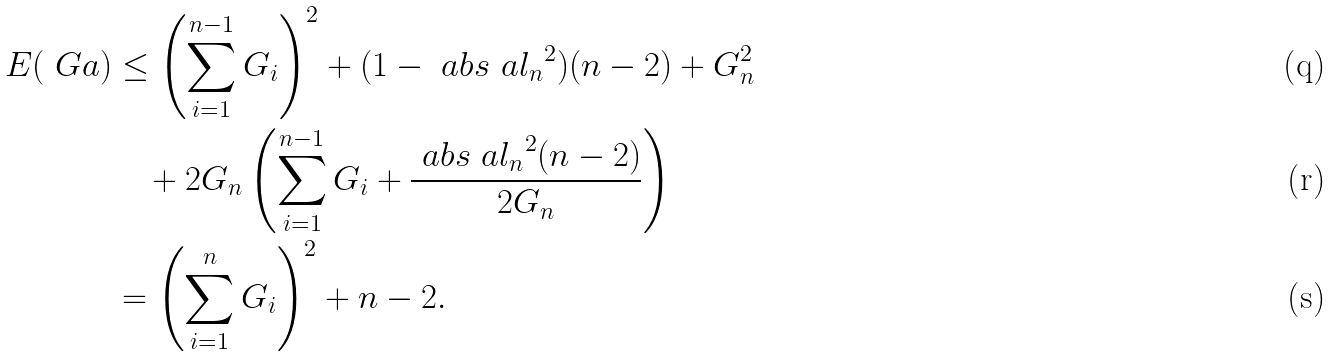<formula> <loc_0><loc_0><loc_500><loc_500>E ( \ G a ) & \leq \left ( \sum _ { i = 1 } ^ { n - 1 } G _ { i } \right ) ^ { 2 } + ( 1 - \ a b s { \ a l _ { n } } ^ { 2 } ) ( n - 2 ) + G _ { n } ^ { 2 } \\ & \quad + 2 G _ { n } \left ( \sum _ { i = 1 } ^ { n - 1 } G _ { i } + \frac { \ a b s { \ a l _ { n } } ^ { 2 } ( n - 2 ) } { 2 G _ { n } } \right ) \\ & = \left ( \sum _ { i = 1 } ^ { n } G _ { i } \right ) ^ { 2 } + n - 2 .</formula> 